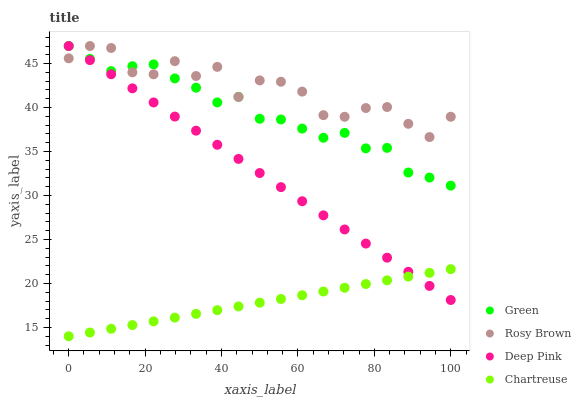Does Chartreuse have the minimum area under the curve?
Answer yes or no. Yes. Does Rosy Brown have the maximum area under the curve?
Answer yes or no. Yes. Does Green have the minimum area under the curve?
Answer yes or no. No. Does Green have the maximum area under the curve?
Answer yes or no. No. Is Chartreuse the smoothest?
Answer yes or no. Yes. Is Rosy Brown the roughest?
Answer yes or no. Yes. Is Green the smoothest?
Answer yes or no. No. Is Green the roughest?
Answer yes or no. No. Does Chartreuse have the lowest value?
Answer yes or no. Yes. Does Green have the lowest value?
Answer yes or no. No. Does Deep Pink have the highest value?
Answer yes or no. Yes. Is Chartreuse less than Green?
Answer yes or no. Yes. Is Rosy Brown greater than Chartreuse?
Answer yes or no. Yes. Does Green intersect Rosy Brown?
Answer yes or no. Yes. Is Green less than Rosy Brown?
Answer yes or no. No. Is Green greater than Rosy Brown?
Answer yes or no. No. Does Chartreuse intersect Green?
Answer yes or no. No. 